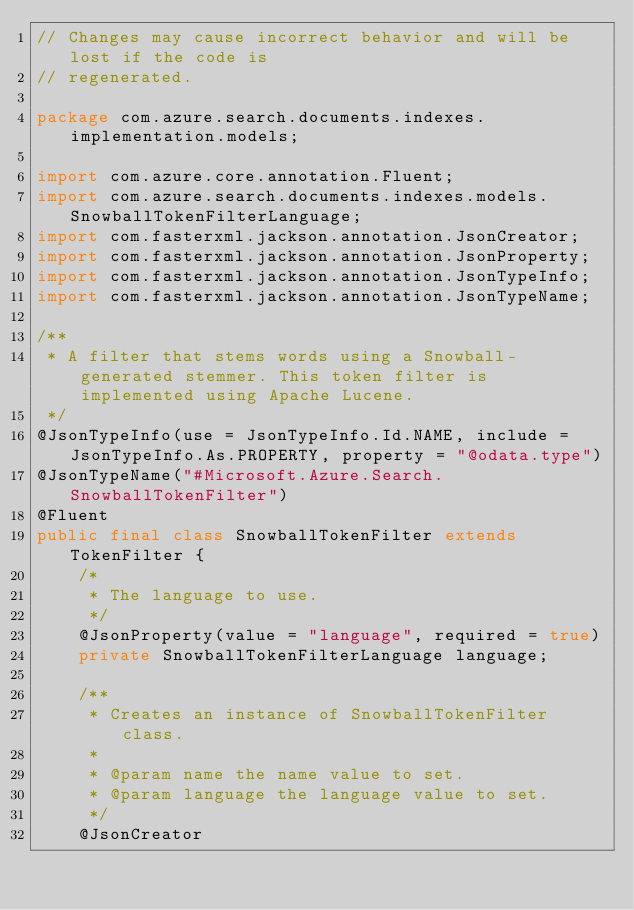<code> <loc_0><loc_0><loc_500><loc_500><_Java_>// Changes may cause incorrect behavior and will be lost if the code is
// regenerated.

package com.azure.search.documents.indexes.implementation.models;

import com.azure.core.annotation.Fluent;
import com.azure.search.documents.indexes.models.SnowballTokenFilterLanguage;
import com.fasterxml.jackson.annotation.JsonCreator;
import com.fasterxml.jackson.annotation.JsonProperty;
import com.fasterxml.jackson.annotation.JsonTypeInfo;
import com.fasterxml.jackson.annotation.JsonTypeName;

/**
 * A filter that stems words using a Snowball-generated stemmer. This token filter is implemented using Apache Lucene.
 */
@JsonTypeInfo(use = JsonTypeInfo.Id.NAME, include = JsonTypeInfo.As.PROPERTY, property = "@odata.type")
@JsonTypeName("#Microsoft.Azure.Search.SnowballTokenFilter")
@Fluent
public final class SnowballTokenFilter extends TokenFilter {
    /*
     * The language to use.
     */
    @JsonProperty(value = "language", required = true)
    private SnowballTokenFilterLanguage language;

    /**
     * Creates an instance of SnowballTokenFilter class.
     *
     * @param name the name value to set.
     * @param language the language value to set.
     */
    @JsonCreator</code> 